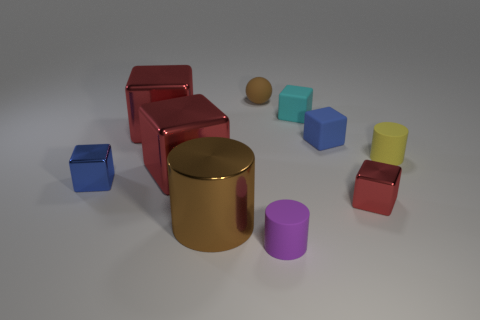Subtract all green cylinders. How many red cubes are left? 3 Subtract all blue blocks. How many blocks are left? 4 Subtract all rubber blocks. How many blocks are left? 4 Subtract all brown blocks. Subtract all red balls. How many blocks are left? 6 Subtract all blocks. How many objects are left? 4 Subtract all brown spheres. Subtract all tiny blue things. How many objects are left? 7 Add 4 metallic things. How many metallic things are left? 9 Add 6 big brown metallic cylinders. How many big brown metallic cylinders exist? 7 Subtract 0 gray spheres. How many objects are left? 10 